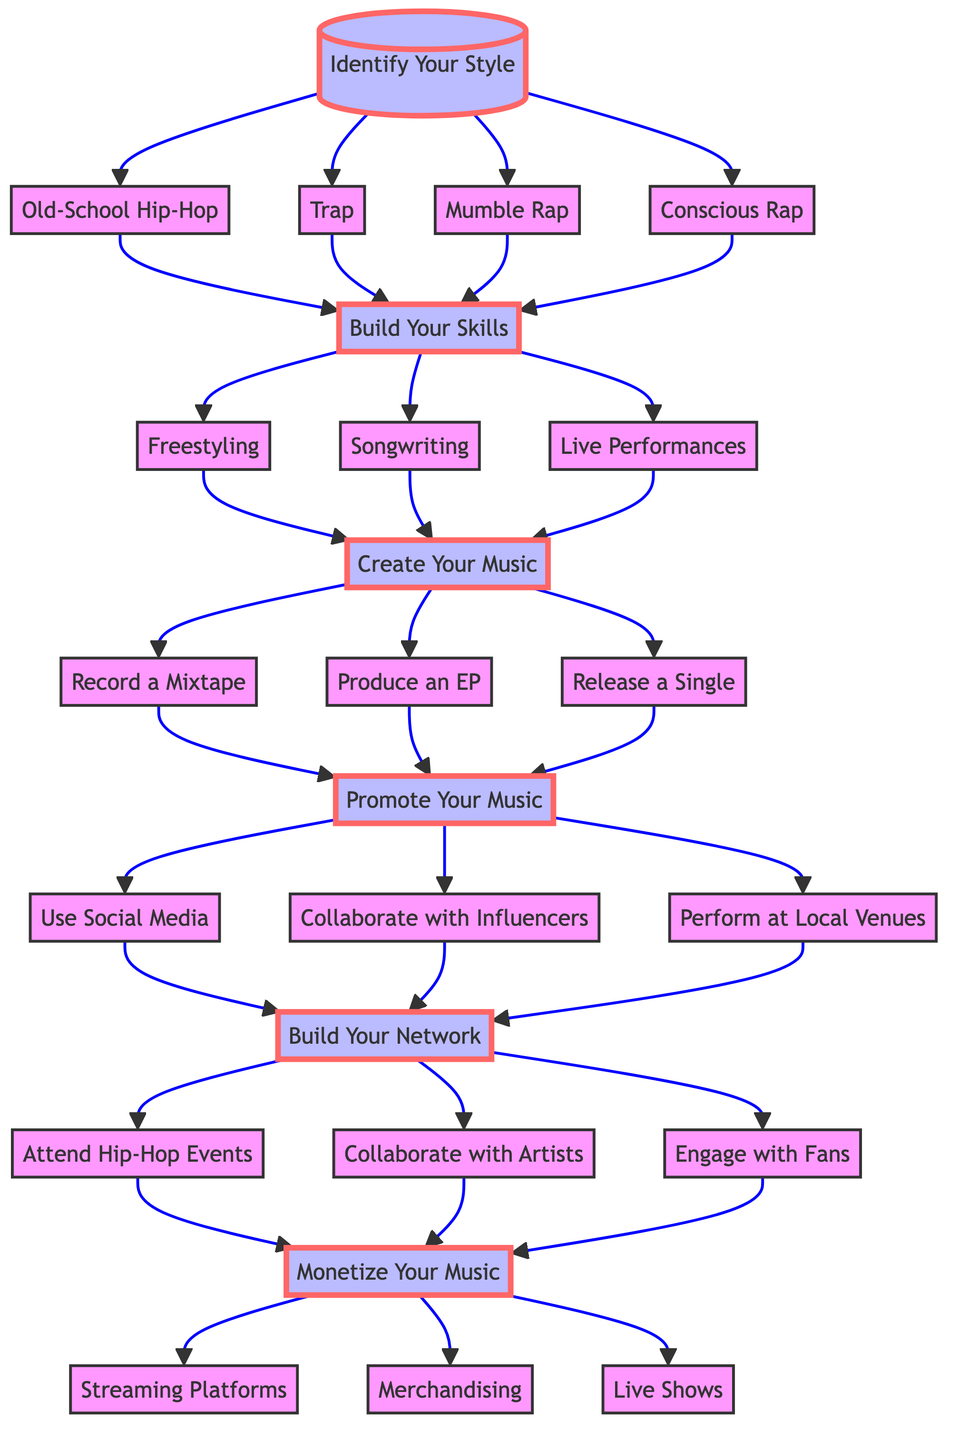What is the first step in the career path? The first step represented in the diagram is the node labeled "Identify Your Style" at the top of the tree. This serves as the starting point for the decision-making process.
Answer: Identify Your Style How many styles are identified in the diagram? There are four different styles listed: Old-School Hip-Hop, Trap, Mumble Rap, and Conscious Rap, making a total of four distinct options in this decision branch.
Answer: Four What is the last step that follows “Monetize Your Music”? Following "Monetize Your Music," the last step presented is "Live Shows," indicating it's one of the final actions after monetization strategies.
Answer: Live Shows What node comes after “Trap”? After selecting "Trap," the next node is "Build Your Skills," which indicates that skills development follows this style choice.
Answer: Build Your Skills Which two nodes lead to “Collaborate with Artists”? The nodes that lead to "Collaborate with Artists" are "Attend Hip-Hop Events" and "Engage with Fans," showing different paths that connect to this collaboration stage.
Answer: Attend Hip-Hop Events and Engage with Fans How many options exist under the “Create Your Music” node? There are three options listed under the "Create Your Music" node: "Record a Mixtape," "Produce an EP," and "Release a Single," giving a total of three possible actions.
Answer: Three What is the relationship between "Promote Your Music" and "Build Your Network"? "Promote Your Music" occurs after completing the steps associated with creating music, while "Build Your Network" occurs after promoting it, indicating that networking is an important step post-promotion.
Answer: Sequential relationship Which step involves interacting with followers? The node that involves interacting with followers is "Engage with Fans," emphasizing the importance of fan engagement in the artist's career path.
Answer: Engage with Fans What do you do after “Record a Mixtape”? After "Record a Mixtape," you can either "Produce an EP," or "Release a Single," presenting the next steps you can take after recording.
Answer: Produce an EP or Release a Single 